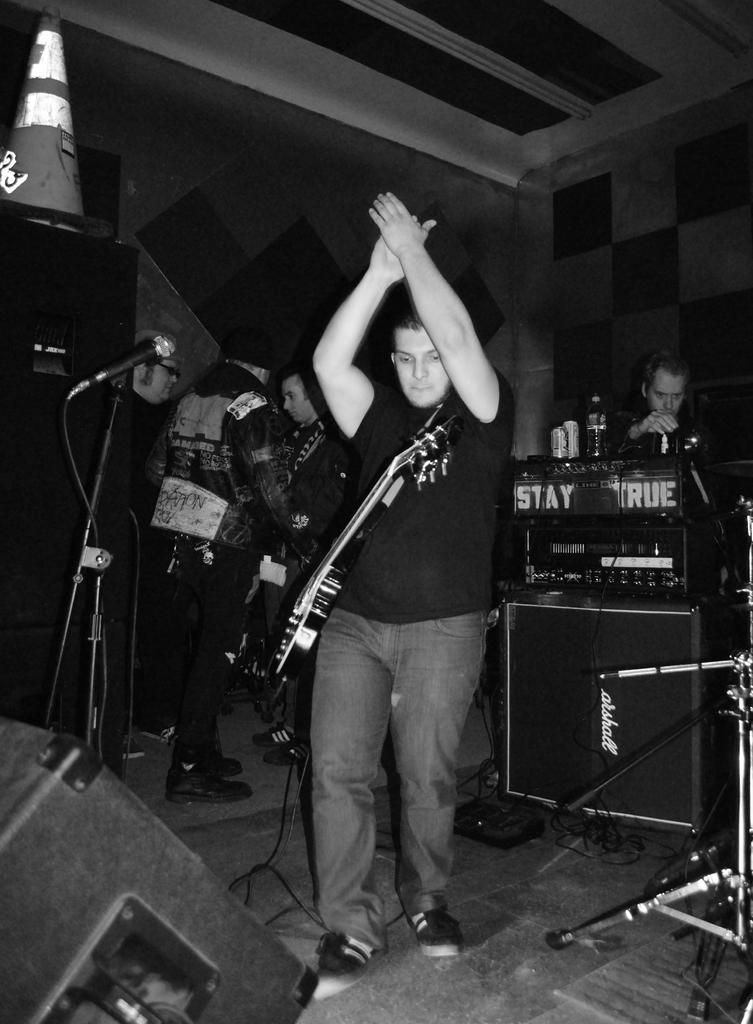How would you summarize this image in a sentence or two? In this image, In the middle there is a man standing and he is carrying a music instrument which is in white color, In the left side there is a microphone which is in black color, In the background there are some people standing. 